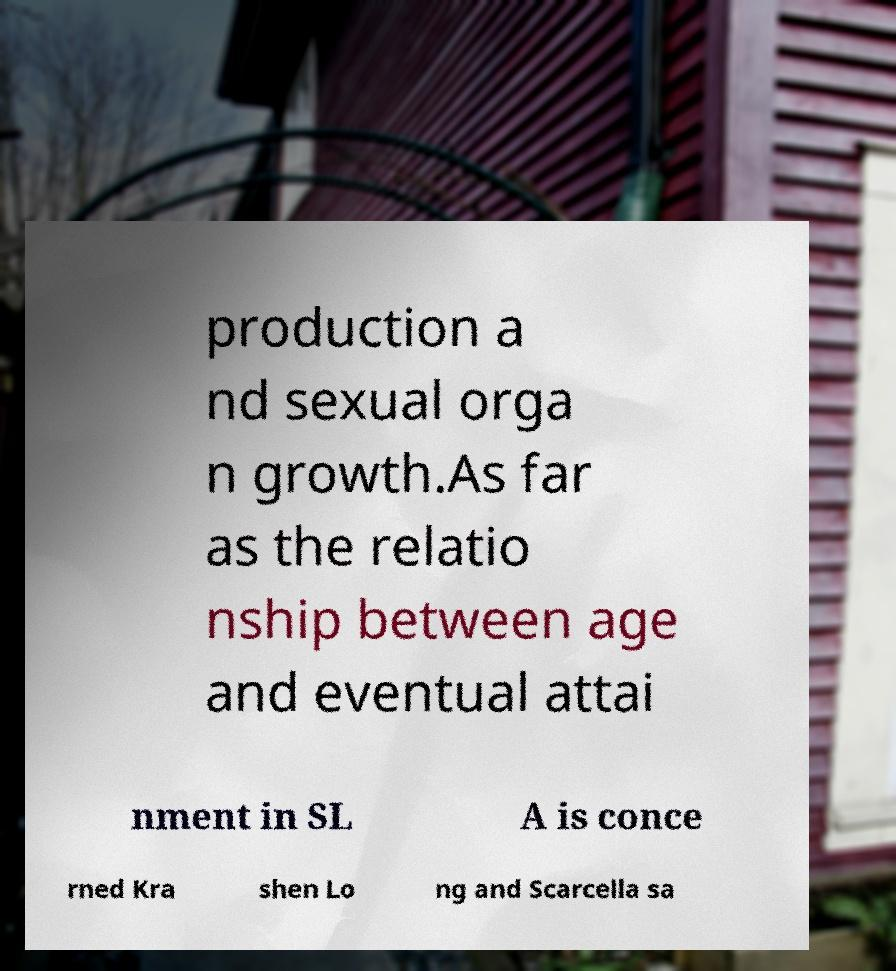I need the written content from this picture converted into text. Can you do that? production a nd sexual orga n growth.As far as the relatio nship between age and eventual attai nment in SL A is conce rned Kra shen Lo ng and Scarcella sa 